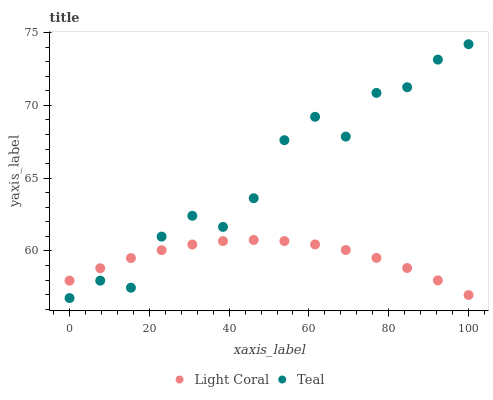Does Light Coral have the minimum area under the curve?
Answer yes or no. Yes. Does Teal have the maximum area under the curve?
Answer yes or no. Yes. Does Teal have the minimum area under the curve?
Answer yes or no. No. Is Light Coral the smoothest?
Answer yes or no. Yes. Is Teal the roughest?
Answer yes or no. Yes. Is Teal the smoothest?
Answer yes or no. No. Does Teal have the lowest value?
Answer yes or no. Yes. Does Teal have the highest value?
Answer yes or no. Yes. Does Teal intersect Light Coral?
Answer yes or no. Yes. Is Teal less than Light Coral?
Answer yes or no. No. Is Teal greater than Light Coral?
Answer yes or no. No. 